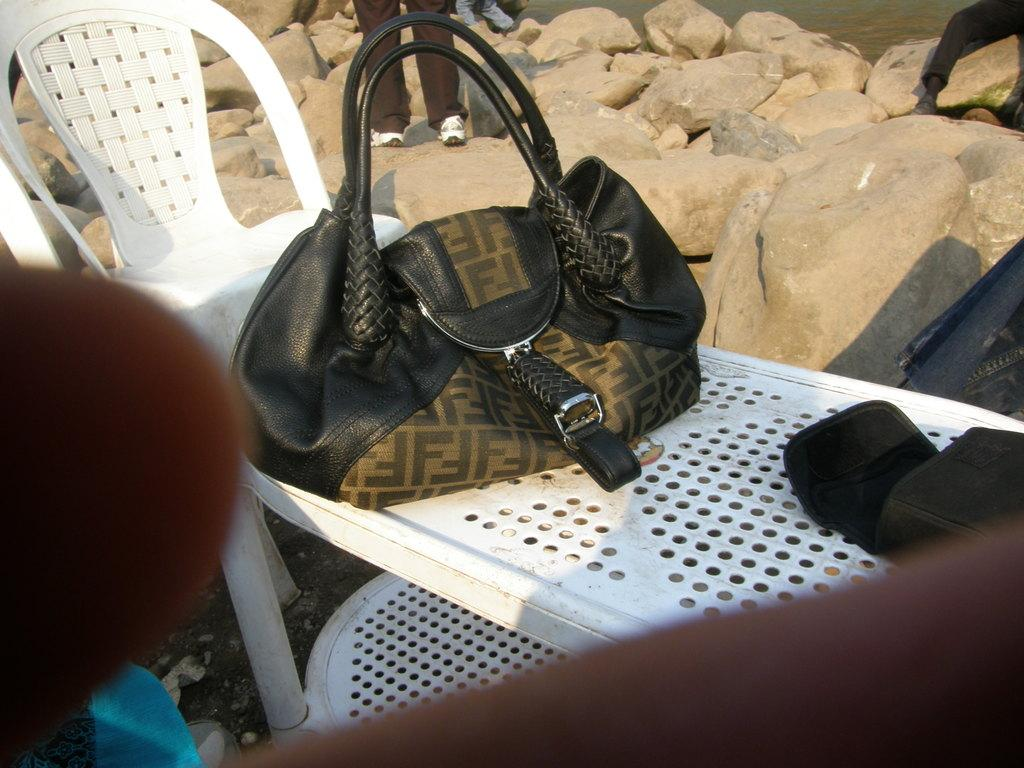What piece of furniture is present in the image? There is a table in the image. What is placed on the table? A bag is kept on the table. Where is the chair located in relation to the table? There is a chair to the left of the table. What can be seen in the background of the image? There are rocks in the background of the image. Who is present in the image? A man is standing in the middle of the image. What type of tax is being discussed in the image? There is no discussion of tax in the image; it features a table, a bag, a chair, rocks, and a man standing in the middle. What trail is visible in the image? There is no trail visible in the image; it features a table, a bag, a chair, rocks, and a man standing in the middle. 